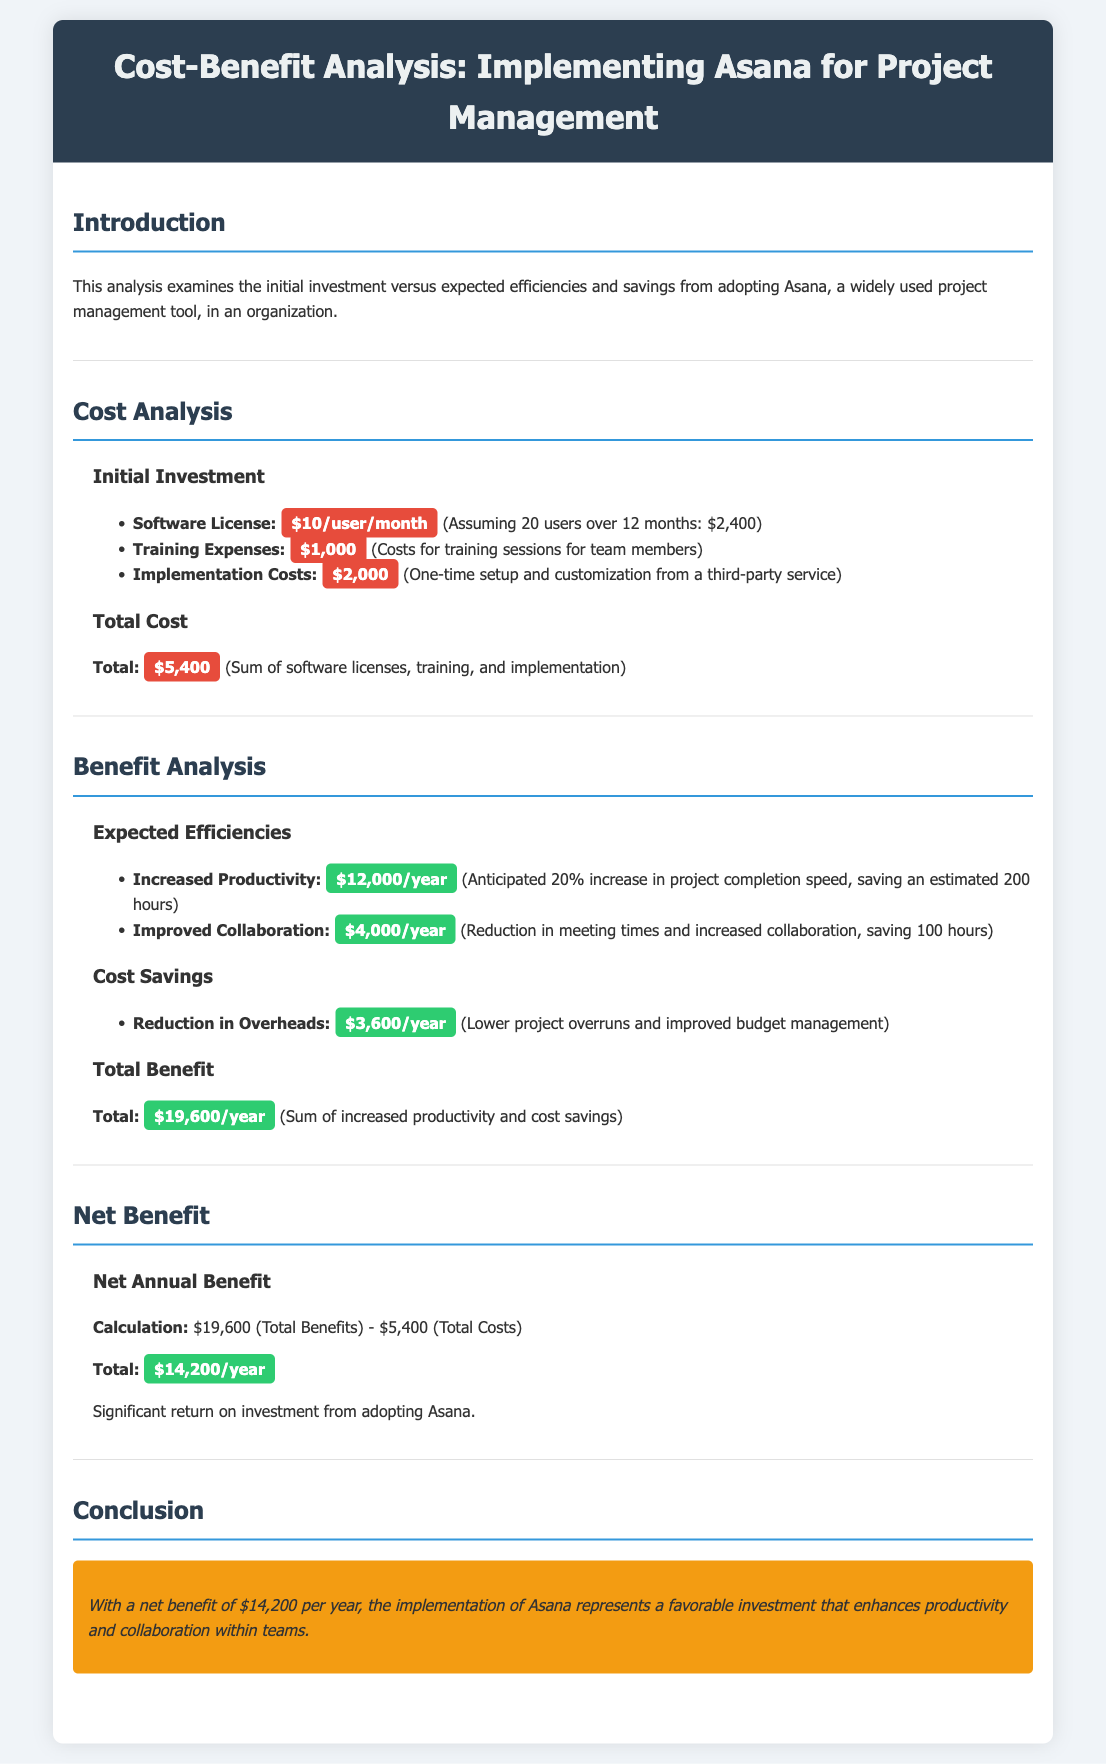What is the monthly cost per user for the software license? The monthly cost per user for the software license is stated in the initial investment section as $10/user/month.
Answer: $10/user/month What is the total cost of implementing Asana? The total cost is a sum of all expenses detailed in the cost analysis, which is $5,400.
Answer: $5,400 What is the projected annual increase in productivity? The expected increase in productivity is mentioned as $12,000/year due to a 20% increase in project completion speed.
Answer: $12,000/year What is the total annual benefit from adopting Asana? The total annual benefit is calculated as the sum of increased productivity and cost savings, amounting to $19,600/year.
Answer: $19,600/year What is the net annual benefit from implementing Asana? The net annual benefit is calculated by subtracting total costs from total benefits, which results in $14,200/year.
Answer: $14,200/year What are the training expenses for implementing Asana? The training expenses listed in the document for training sessions for team members are $1,000.
Answer: $1,000 How much is saved annually due to reduced overheads? The annual savings due to reduction in overheads are reported as $3,600/year.
Answer: $3,600/year What is the conclusion regarding the implementation of Asana? The conclusion states that the implementation represents a favorable investment enhancing productivity and collaboration, emphasizing the net benefit.
Answer: Favorable investment 